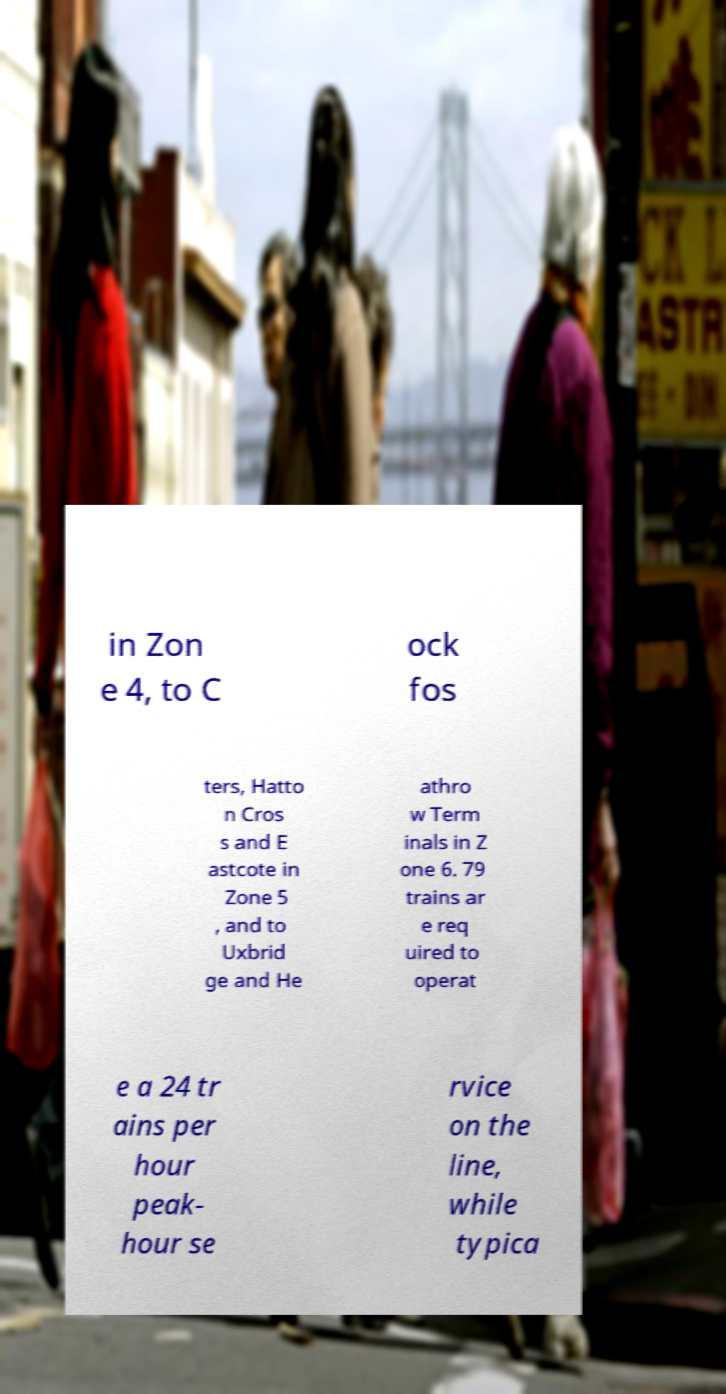What messages or text are displayed in this image? I need them in a readable, typed format. in Zon e 4, to C ock fos ters, Hatto n Cros s and E astcote in Zone 5 , and to Uxbrid ge and He athro w Term inals in Z one 6. 79 trains ar e req uired to operat e a 24 tr ains per hour peak- hour se rvice on the line, while typica 